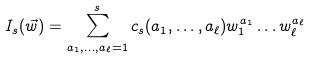<formula> <loc_0><loc_0><loc_500><loc_500>I _ { s } ( \vec { w } ) = \sum _ { a _ { 1 } , \dots , a _ { \ell } = 1 } ^ { s } c _ { s } ( a _ { 1 } , \dots , a _ { \ell } ) w _ { 1 } ^ { a _ { 1 } } \dots w _ { \ell } ^ { a _ { \ell } }</formula> 